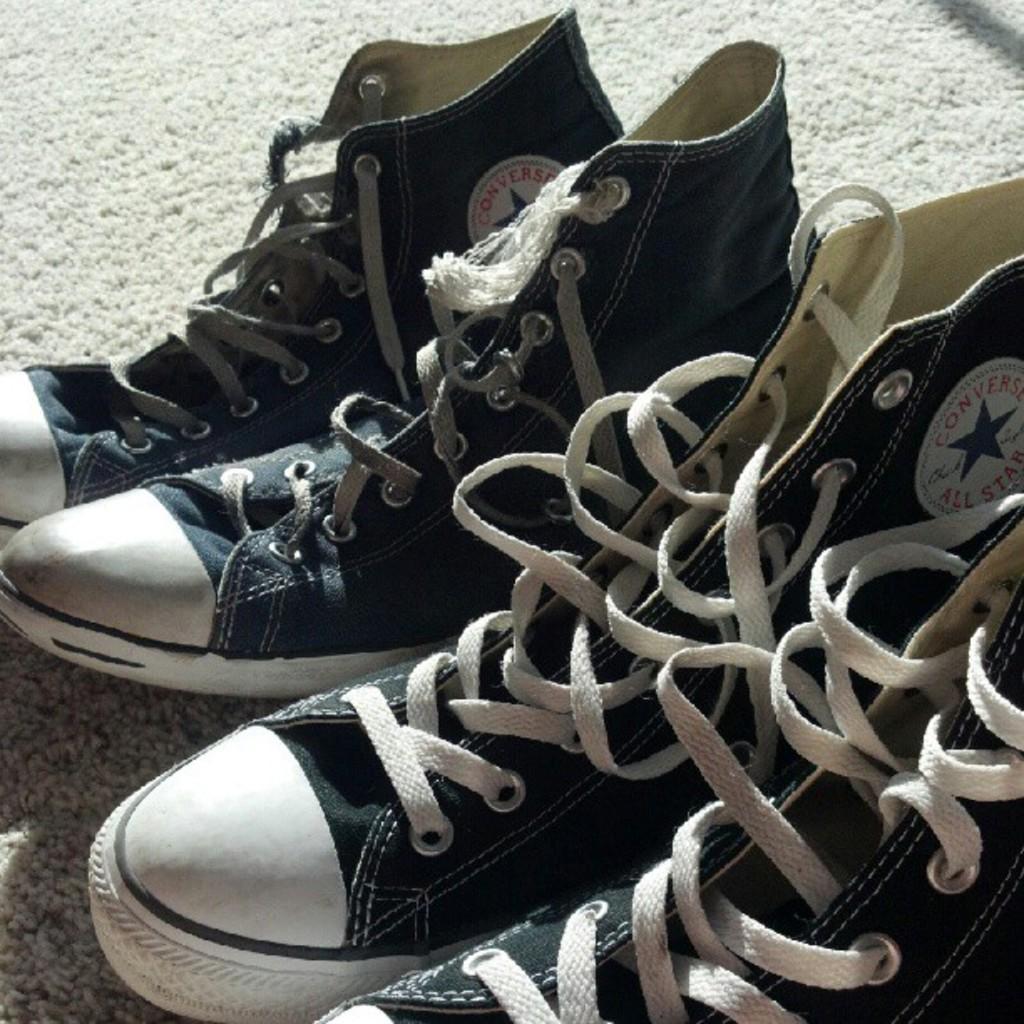In one or two sentences, can you explain what this image depicts? In this image we can see two pairs of shoes on the mat. 